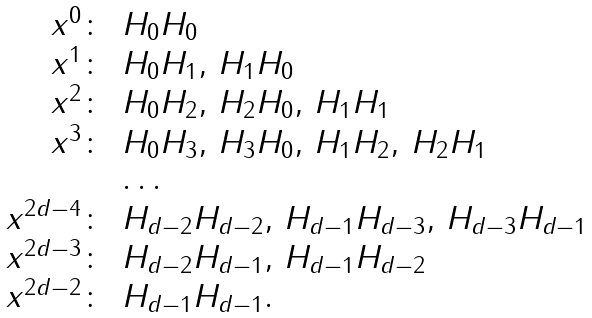Convert formula to latex. <formula><loc_0><loc_0><loc_500><loc_500>\begin{array} { r l l l l } x ^ { 0 } \colon & H _ { 0 } H _ { 0 } \\ x ^ { 1 } \colon & H _ { 0 } H _ { 1 } , \, H _ { 1 } H _ { 0 } \\ x ^ { 2 } \colon & H _ { 0 } H _ { 2 } , \, H _ { 2 } H _ { 0 } , \, H _ { 1 } H _ { 1 } \\ x ^ { 3 } \colon & H _ { 0 } H _ { 3 } , \, H _ { 3 } H _ { 0 } , \, H _ { 1 } H _ { 2 } , \, H _ { 2 } H _ { 1 } \\ & \dots \\ x ^ { 2 d - 4 } \colon & H _ { d - 2 } H _ { d - 2 } , \, H _ { d - 1 } H _ { d - 3 } , \, H _ { d - 3 } H _ { d - 1 } \\ x ^ { 2 d - 3 } \colon & H _ { d - 2 } H _ { d - 1 } , \, H _ { d - 1 } H _ { d - 2 } \\ x ^ { 2 d - 2 } \colon & H _ { d - 1 } H _ { d - 1 } . \\ \end{array}</formula> 